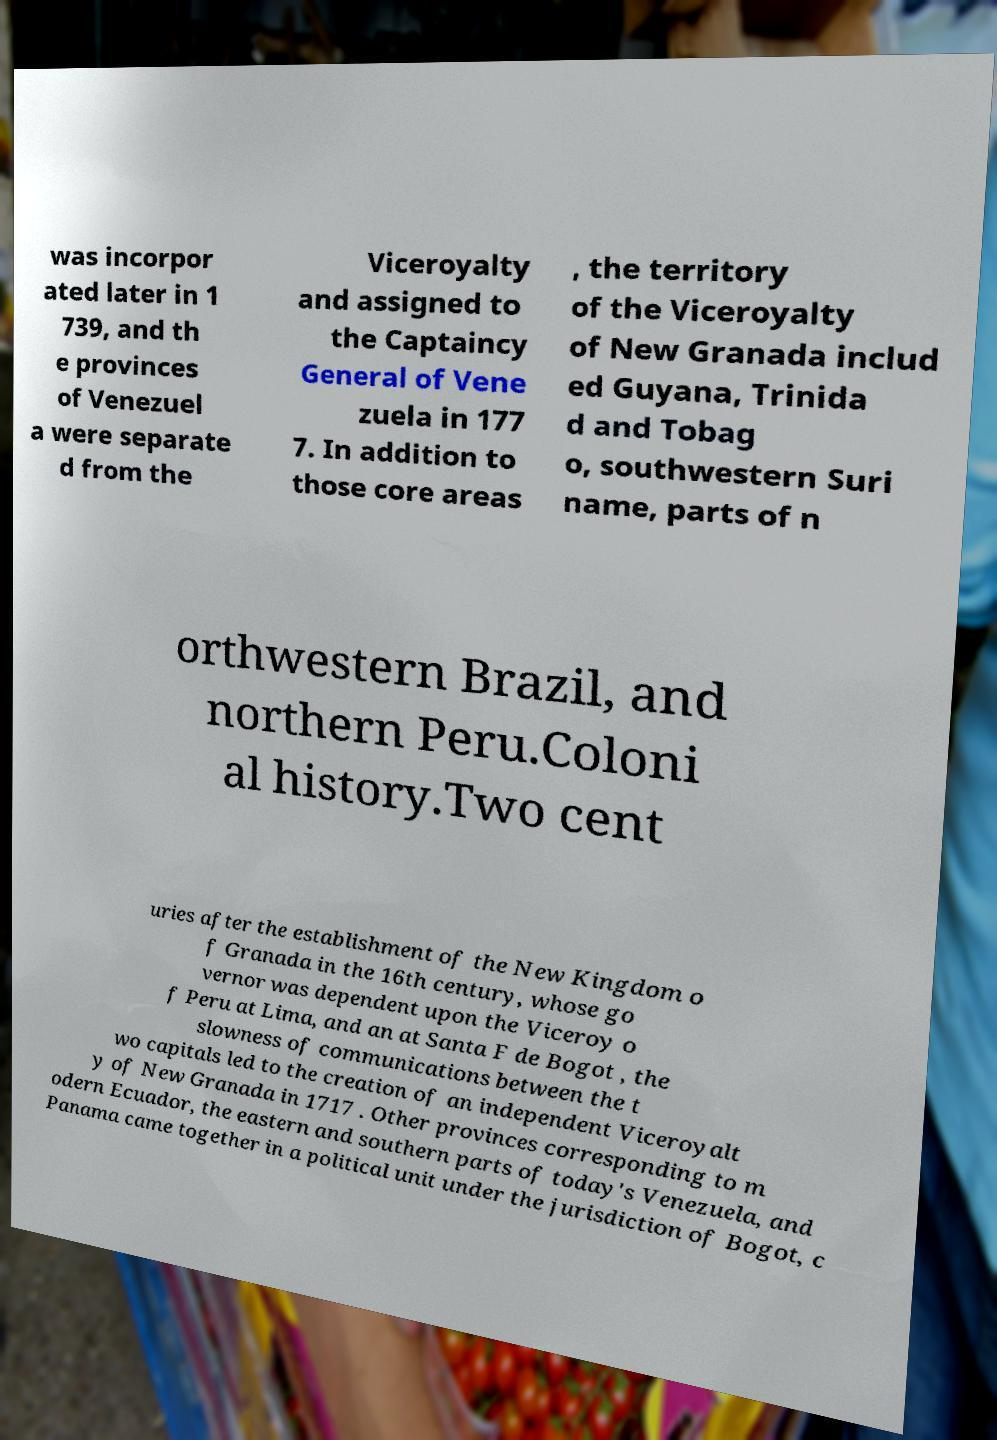For documentation purposes, I need the text within this image transcribed. Could you provide that? was incorpor ated later in 1 739, and th e provinces of Venezuel a were separate d from the Viceroyalty and assigned to the Captaincy General of Vene zuela in 177 7. In addition to those core areas , the territory of the Viceroyalty of New Granada includ ed Guyana, Trinida d and Tobag o, southwestern Suri name, parts of n orthwestern Brazil, and northern Peru.Coloni al history.Two cent uries after the establishment of the New Kingdom o f Granada in the 16th century, whose go vernor was dependent upon the Viceroy o f Peru at Lima, and an at Santa F de Bogot , the slowness of communications between the t wo capitals led to the creation of an independent Viceroyalt y of New Granada in 1717 . Other provinces corresponding to m odern Ecuador, the eastern and southern parts of today's Venezuela, and Panama came together in a political unit under the jurisdiction of Bogot, c 